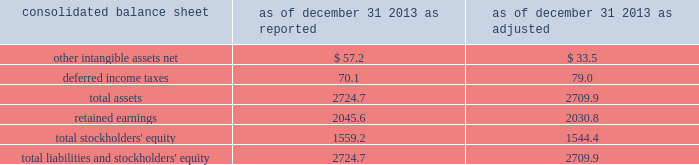Edwards lifesciences corporation notes to consolidated financial statements ( continued ) 2 .
Summary of significant accounting policies ( continued ) interim periods therein .
The new guidance can be applied retrospectively to each prior reporting period presented or retrospectively with the cumulative effect of the change recognized at the date of the initial application .
The company is currently assessing the impact this guidance will have on its consolidated financial statements , and has not yet selected a transition method .
Change in accounting principle effective january 1 , 2014 , the company changed its method of accounting for certain intellectual property litigation expenses related to the defense and enforcement of its issued patents .
Previously , the company capitalized these legal costs if a favorable outcome in the patent defense was determined to be probable , and amortized the capitalized legal costs over the life of the related patent .
As of december 31 , 2013 , the company had remaining unamortized capitalized legal costs of $ 23.7 million , which , under the previous accounting method , would have been amortized through 2021 .
Under the new method of accounting , these legal costs are expensed in the period they are incurred .
The company has retrospectively adjusted the comparative financial statements of prior periods to apply this new method of accounting .
The company believes this change in accounting principle is preferable because ( 1 ) as more competitors enter the company 2019s key product markets and the threat of complex intellectual property litigation across multiple jurisdictions increases , it will become more difficult for the company to accurately assess the probability of a favorable outcome in such litigation , and ( 2 ) it will enhance the comparability of the company 2019s financial results with those of its peer group because it is the predominant accounting practice in the company 2019s industry .
The accompanying consolidated financial statements and related notes have been adjusted to reflect the impact of this change retrospectively to all prior periods presented .
The cumulative effect of the change in accounting principle was a decrease in retained earnings of $ 10.5 million as of january 1 , 2012 .
The tables present the effects of the retrospective application of the change in accounting principle ( in millions ) : .

What was the affect of the change in accounting principles on differed income taxes in millions? 
Computations: (79.0 - 70.1)
Answer: 8.9. 